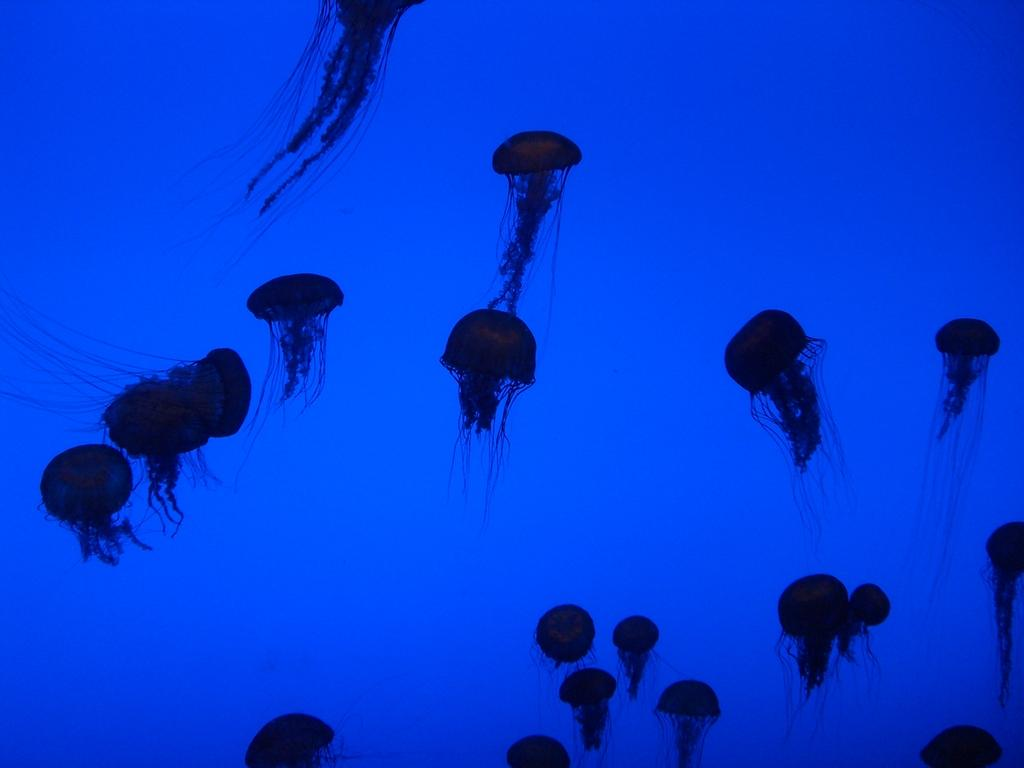What type of marine animals are present in the image? There are jellyfishes in the image. What religious story is depicted in the image? There is no religious story depicted in the image; it features jellyfishes. What unit of measurement is used to describe the size of the jellyfishes in the image? The provided facts do not mention any specific unit of measurement for describing the size of the jellyfishes in the image. 